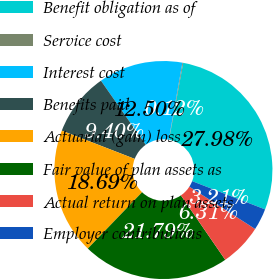Convert chart to OTSL. <chart><loc_0><loc_0><loc_500><loc_500><pie_chart><fcel>Benefit obligation as of<fcel>Service cost<fcel>Interest cost<fcel>Benefits paid<fcel>Actuarial (gain) loss<fcel>Fair value of plan assets as<fcel>Actual return on plan assets<fcel>Employer contributions<nl><fcel>27.98%<fcel>0.12%<fcel>12.5%<fcel>9.4%<fcel>18.69%<fcel>21.79%<fcel>6.31%<fcel>3.21%<nl></chart> 